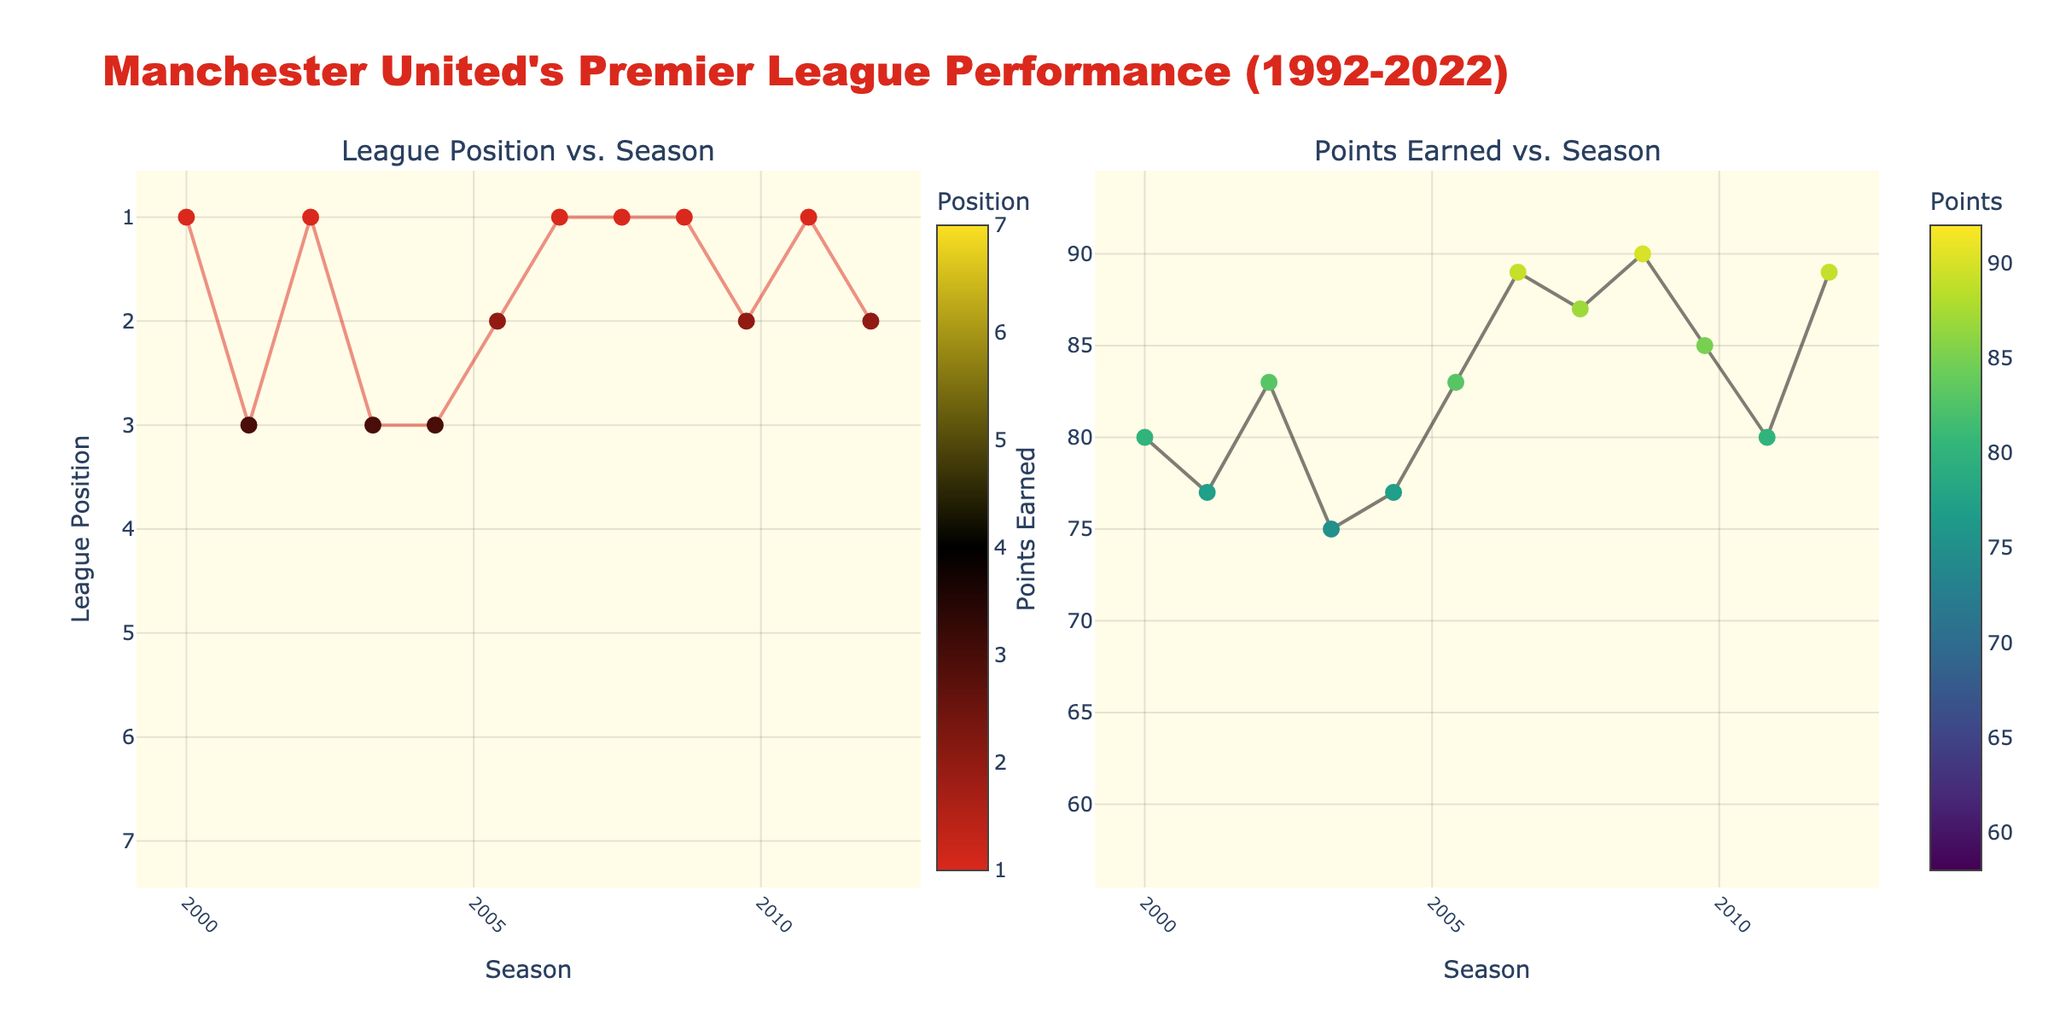What is the title of the plot on the left side? The title is located above the corresponding plot, with each subplot having its own descriptive title. Look at the top of the left scatter plot to find the title mentioning "League Position vs. Season".
Answer: League Position vs. Season What color represents the highest points earned in the right plot? The color bar next to the right scatter plot indicates the gradient. The highest points earned would be represented by the most intense color at the end of the color scale. In this instance, the color scheme "Viridis" typically ends with a bright yellow color.
Answer: Bright yellow In which season did Manchester United earn the lowest points? Check the right scatter plot and locate the lowest point on the y-axis, then trace it to its corresponding position on the x-axis which represents the season.
Answer: 2021-22 How many times did Manchester United finish in 1st place over the seasons shown? Look at the left scatter plot, particularly for multiple data points at y=1 (the top of the y-axis since it's reversed); count these points.
Answer: 13 times In which seasons did Manchester United finish in 2nd place but earned more than 80 points? Identify the data points in the left scatter plot where the league position is 2, then cross-reference these points with those in the right plot where the points earned are more than 80.
Answer: 1994-95, 2009-10, 2017-18, 2011-12 What is the average league position for Manchester United between 2000-2001 and 2010-2011? Add up the league positions from each season between 2000-2001 and 2010-2011, then divide by the number of seasons in this range. (3 + 1 + 3 + 2 + 1 + 1 + 1 + 2 + 1 + 1) / 10 = 18 / 10 = 1.8
Answer: 1.8 Which season had the biggest drop in points earned compared to the previous season? Examine the right plot and calculate the differences between points of consecutive seasons, identifying the largest decrease. The biggest drop is between 2012-13 (89 points) and 2013-14 (64 points), with a difference of 25 points.
Answer: 2013-14 How does the curve's trend in "Points Earned vs. Season" relate to Manchester United's overall performance? Evaluate the general upward or downward movements in the right plot's curve. Multiple high peaks generally correspond to winning seasons; identify if, over time, the curve trends higher or lower to understand the performance.
Answer: Varied with a slight downward trend in recent years How many points did Manchester United earn in the 1998-99 season? Locate the 1998-99 data point in the right scatter plot on the x-axis, trace vertically to find the corresponding y-axis value for points earned.
Answer: 79 points 